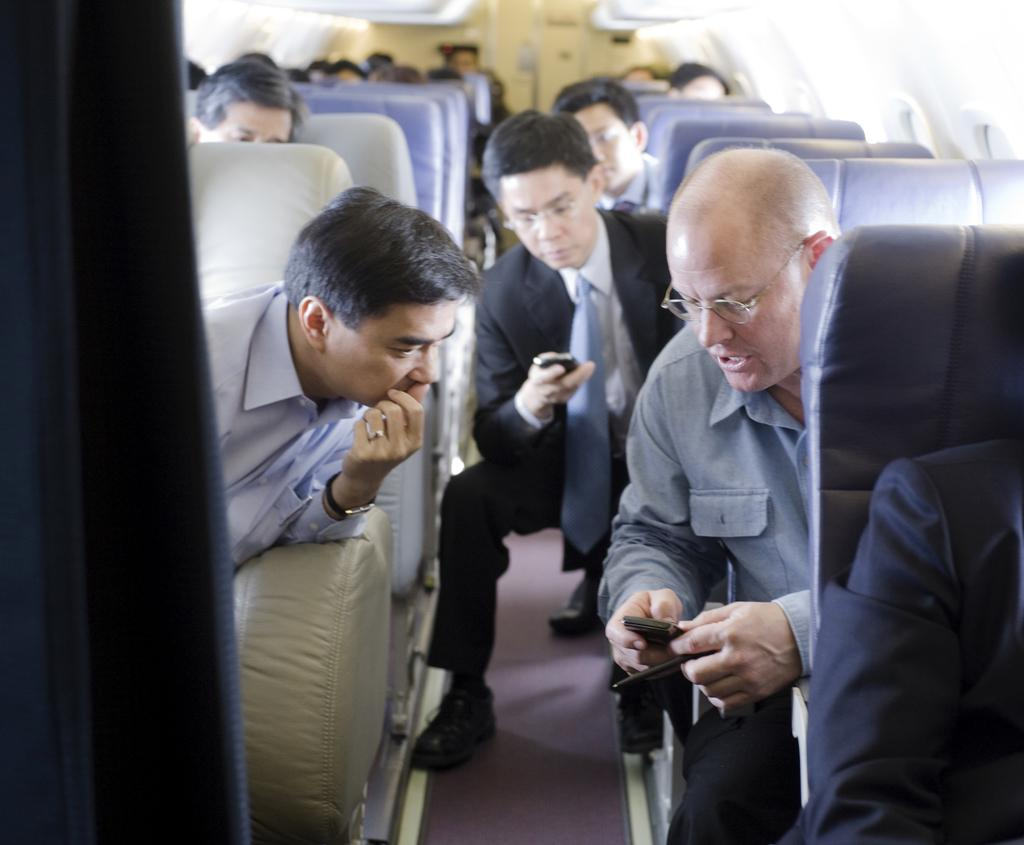What type of location is depicted in the image? The image is an inside view of an aeroplane. What are the people in the image doing? The people in the image are sitting in the aeroplane. What objects are the people holding in their hands? The people are holding mobiles in their hands. What direction is the mom facing in the image? There is no mention of a mom or a specific direction in the image. 